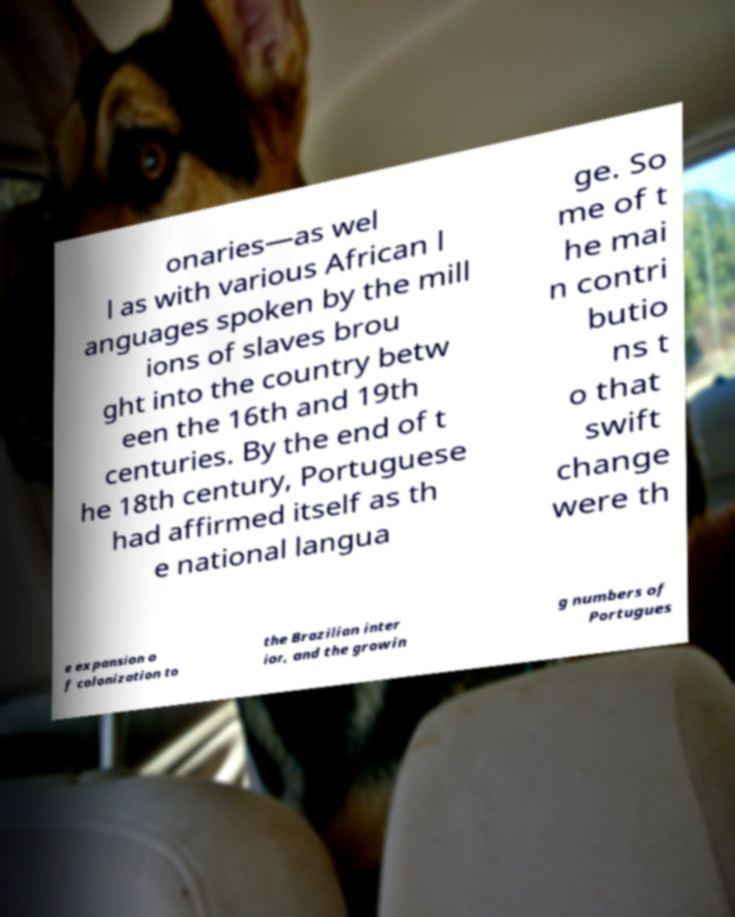Could you extract and type out the text from this image? onaries—as wel l as with various African l anguages spoken by the mill ions of slaves brou ght into the country betw een the 16th and 19th centuries. By the end of t he 18th century, Portuguese had affirmed itself as th e national langua ge. So me of t he mai n contri butio ns t o that swift change were th e expansion o f colonization to the Brazilian inter ior, and the growin g numbers of Portugues 